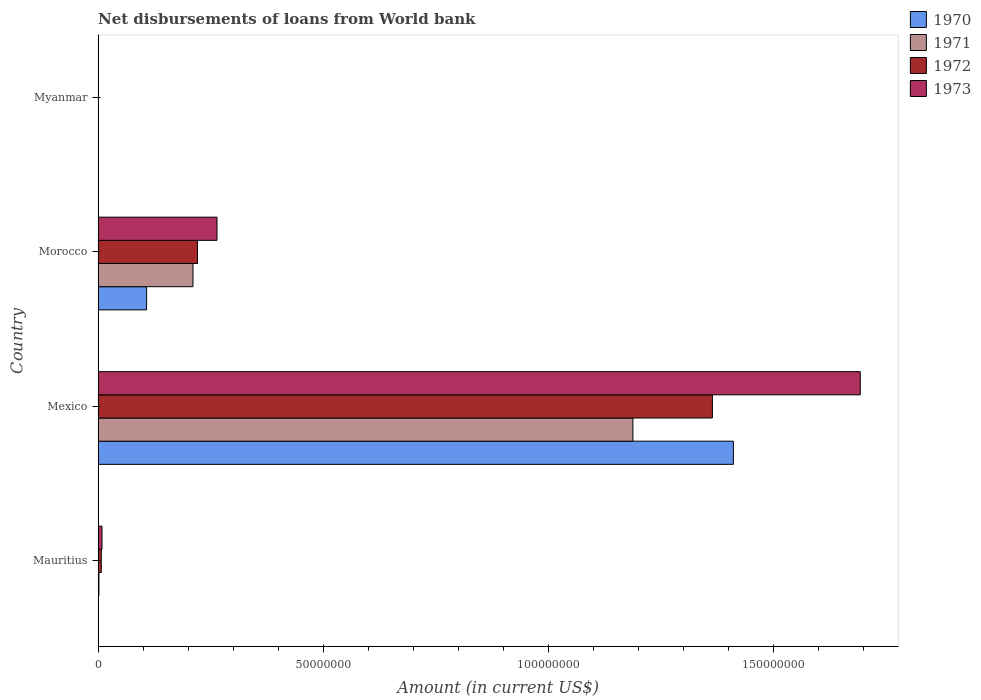Are the number of bars per tick equal to the number of legend labels?
Provide a short and direct response. No. How many bars are there on the 1st tick from the top?
Your answer should be very brief. 0. What is the label of the 2nd group of bars from the top?
Provide a short and direct response. Morocco. In how many cases, is the number of bars for a given country not equal to the number of legend labels?
Your answer should be very brief. 2. What is the amount of loan disbursed from World Bank in 1973 in Mexico?
Ensure brevity in your answer.  1.69e+08. Across all countries, what is the maximum amount of loan disbursed from World Bank in 1972?
Offer a very short reply. 1.36e+08. In which country was the amount of loan disbursed from World Bank in 1973 maximum?
Provide a succinct answer. Mexico. What is the total amount of loan disbursed from World Bank in 1970 in the graph?
Offer a terse response. 1.52e+08. What is the difference between the amount of loan disbursed from World Bank in 1972 in Mauritius and that in Morocco?
Keep it short and to the point. -2.14e+07. What is the difference between the amount of loan disbursed from World Bank in 1971 in Morocco and the amount of loan disbursed from World Bank in 1970 in Myanmar?
Offer a very short reply. 2.11e+07. What is the average amount of loan disbursed from World Bank in 1971 per country?
Offer a very short reply. 3.50e+07. What is the difference between the amount of loan disbursed from World Bank in 1972 and amount of loan disbursed from World Bank in 1973 in Mexico?
Offer a terse response. -3.28e+07. What is the ratio of the amount of loan disbursed from World Bank in 1973 in Mexico to that in Morocco?
Keep it short and to the point. 6.41. Is the amount of loan disbursed from World Bank in 1973 in Mexico less than that in Morocco?
Keep it short and to the point. No. What is the difference between the highest and the second highest amount of loan disbursed from World Bank in 1972?
Your response must be concise. 1.14e+08. What is the difference between the highest and the lowest amount of loan disbursed from World Bank in 1970?
Make the answer very short. 1.41e+08. In how many countries, is the amount of loan disbursed from World Bank in 1973 greater than the average amount of loan disbursed from World Bank in 1973 taken over all countries?
Provide a succinct answer. 1. Are the values on the major ticks of X-axis written in scientific E-notation?
Give a very brief answer. No. Does the graph contain any zero values?
Your response must be concise. Yes. Does the graph contain grids?
Keep it short and to the point. No. Where does the legend appear in the graph?
Your answer should be compact. Top right. How many legend labels are there?
Provide a succinct answer. 4. What is the title of the graph?
Give a very brief answer. Net disbursements of loans from World bank. What is the label or title of the Y-axis?
Keep it short and to the point. Country. What is the Amount (in current US$) in 1971 in Mauritius?
Provide a succinct answer. 1.99e+05. What is the Amount (in current US$) of 1972 in Mauritius?
Give a very brief answer. 7.17e+05. What is the Amount (in current US$) in 1973 in Mauritius?
Make the answer very short. 8.79e+05. What is the Amount (in current US$) in 1970 in Mexico?
Offer a very short reply. 1.41e+08. What is the Amount (in current US$) in 1971 in Mexico?
Your answer should be compact. 1.19e+08. What is the Amount (in current US$) of 1972 in Mexico?
Keep it short and to the point. 1.36e+08. What is the Amount (in current US$) in 1973 in Mexico?
Give a very brief answer. 1.69e+08. What is the Amount (in current US$) in 1970 in Morocco?
Offer a very short reply. 1.08e+07. What is the Amount (in current US$) in 1971 in Morocco?
Your answer should be compact. 2.11e+07. What is the Amount (in current US$) in 1972 in Morocco?
Provide a succinct answer. 2.21e+07. What is the Amount (in current US$) of 1973 in Morocco?
Your response must be concise. 2.64e+07. What is the Amount (in current US$) of 1973 in Myanmar?
Your answer should be compact. 0. Across all countries, what is the maximum Amount (in current US$) in 1970?
Your answer should be very brief. 1.41e+08. Across all countries, what is the maximum Amount (in current US$) of 1971?
Offer a terse response. 1.19e+08. Across all countries, what is the maximum Amount (in current US$) of 1972?
Your response must be concise. 1.36e+08. Across all countries, what is the maximum Amount (in current US$) of 1973?
Your answer should be compact. 1.69e+08. Across all countries, what is the minimum Amount (in current US$) of 1970?
Ensure brevity in your answer.  0. What is the total Amount (in current US$) of 1970 in the graph?
Keep it short and to the point. 1.52e+08. What is the total Amount (in current US$) of 1971 in the graph?
Your response must be concise. 1.40e+08. What is the total Amount (in current US$) of 1972 in the graph?
Make the answer very short. 1.59e+08. What is the total Amount (in current US$) of 1973 in the graph?
Your response must be concise. 1.97e+08. What is the difference between the Amount (in current US$) of 1971 in Mauritius and that in Mexico?
Your response must be concise. -1.19e+08. What is the difference between the Amount (in current US$) of 1972 in Mauritius and that in Mexico?
Give a very brief answer. -1.36e+08. What is the difference between the Amount (in current US$) of 1973 in Mauritius and that in Mexico?
Your answer should be very brief. -1.68e+08. What is the difference between the Amount (in current US$) of 1971 in Mauritius and that in Morocco?
Provide a short and direct response. -2.09e+07. What is the difference between the Amount (in current US$) of 1972 in Mauritius and that in Morocco?
Your response must be concise. -2.14e+07. What is the difference between the Amount (in current US$) in 1973 in Mauritius and that in Morocco?
Your answer should be compact. -2.55e+07. What is the difference between the Amount (in current US$) in 1970 in Mexico and that in Morocco?
Your answer should be compact. 1.30e+08. What is the difference between the Amount (in current US$) of 1971 in Mexico and that in Morocco?
Give a very brief answer. 9.77e+07. What is the difference between the Amount (in current US$) of 1972 in Mexico and that in Morocco?
Provide a short and direct response. 1.14e+08. What is the difference between the Amount (in current US$) in 1973 in Mexico and that in Morocco?
Your response must be concise. 1.43e+08. What is the difference between the Amount (in current US$) in 1971 in Mauritius and the Amount (in current US$) in 1972 in Mexico?
Your answer should be compact. -1.36e+08. What is the difference between the Amount (in current US$) in 1971 in Mauritius and the Amount (in current US$) in 1973 in Mexico?
Your answer should be compact. -1.69e+08. What is the difference between the Amount (in current US$) in 1972 in Mauritius and the Amount (in current US$) in 1973 in Mexico?
Your answer should be very brief. -1.69e+08. What is the difference between the Amount (in current US$) of 1971 in Mauritius and the Amount (in current US$) of 1972 in Morocco?
Your answer should be very brief. -2.19e+07. What is the difference between the Amount (in current US$) in 1971 in Mauritius and the Amount (in current US$) in 1973 in Morocco?
Provide a short and direct response. -2.62e+07. What is the difference between the Amount (in current US$) in 1972 in Mauritius and the Amount (in current US$) in 1973 in Morocco?
Provide a succinct answer. -2.57e+07. What is the difference between the Amount (in current US$) in 1970 in Mexico and the Amount (in current US$) in 1971 in Morocco?
Your answer should be very brief. 1.20e+08. What is the difference between the Amount (in current US$) in 1970 in Mexico and the Amount (in current US$) in 1972 in Morocco?
Keep it short and to the point. 1.19e+08. What is the difference between the Amount (in current US$) of 1970 in Mexico and the Amount (in current US$) of 1973 in Morocco?
Make the answer very short. 1.15e+08. What is the difference between the Amount (in current US$) of 1971 in Mexico and the Amount (in current US$) of 1972 in Morocco?
Provide a short and direct response. 9.67e+07. What is the difference between the Amount (in current US$) in 1971 in Mexico and the Amount (in current US$) in 1973 in Morocco?
Offer a terse response. 9.24e+07. What is the difference between the Amount (in current US$) in 1972 in Mexico and the Amount (in current US$) in 1973 in Morocco?
Ensure brevity in your answer.  1.10e+08. What is the average Amount (in current US$) of 1970 per country?
Provide a succinct answer. 3.80e+07. What is the average Amount (in current US$) of 1971 per country?
Your response must be concise. 3.50e+07. What is the average Amount (in current US$) in 1972 per country?
Your answer should be very brief. 3.98e+07. What is the average Amount (in current US$) in 1973 per country?
Make the answer very short. 4.91e+07. What is the difference between the Amount (in current US$) of 1971 and Amount (in current US$) of 1972 in Mauritius?
Your response must be concise. -5.18e+05. What is the difference between the Amount (in current US$) of 1971 and Amount (in current US$) of 1973 in Mauritius?
Make the answer very short. -6.80e+05. What is the difference between the Amount (in current US$) in 1972 and Amount (in current US$) in 1973 in Mauritius?
Offer a very short reply. -1.62e+05. What is the difference between the Amount (in current US$) of 1970 and Amount (in current US$) of 1971 in Mexico?
Your response must be concise. 2.23e+07. What is the difference between the Amount (in current US$) of 1970 and Amount (in current US$) of 1972 in Mexico?
Give a very brief answer. 4.66e+06. What is the difference between the Amount (in current US$) in 1970 and Amount (in current US$) in 1973 in Mexico?
Make the answer very short. -2.82e+07. What is the difference between the Amount (in current US$) of 1971 and Amount (in current US$) of 1972 in Mexico?
Your answer should be very brief. -1.77e+07. What is the difference between the Amount (in current US$) of 1971 and Amount (in current US$) of 1973 in Mexico?
Your answer should be very brief. -5.05e+07. What is the difference between the Amount (in current US$) in 1972 and Amount (in current US$) in 1973 in Mexico?
Keep it short and to the point. -3.28e+07. What is the difference between the Amount (in current US$) of 1970 and Amount (in current US$) of 1971 in Morocco?
Ensure brevity in your answer.  -1.03e+07. What is the difference between the Amount (in current US$) in 1970 and Amount (in current US$) in 1972 in Morocco?
Give a very brief answer. -1.13e+07. What is the difference between the Amount (in current US$) of 1970 and Amount (in current US$) of 1973 in Morocco?
Your response must be concise. -1.56e+07. What is the difference between the Amount (in current US$) of 1971 and Amount (in current US$) of 1972 in Morocco?
Provide a short and direct response. -1.01e+06. What is the difference between the Amount (in current US$) of 1971 and Amount (in current US$) of 1973 in Morocco?
Provide a succinct answer. -5.34e+06. What is the difference between the Amount (in current US$) of 1972 and Amount (in current US$) of 1973 in Morocco?
Your response must be concise. -4.33e+06. What is the ratio of the Amount (in current US$) of 1971 in Mauritius to that in Mexico?
Your answer should be very brief. 0. What is the ratio of the Amount (in current US$) in 1972 in Mauritius to that in Mexico?
Your response must be concise. 0.01. What is the ratio of the Amount (in current US$) of 1973 in Mauritius to that in Mexico?
Offer a terse response. 0.01. What is the ratio of the Amount (in current US$) of 1971 in Mauritius to that in Morocco?
Your answer should be very brief. 0.01. What is the ratio of the Amount (in current US$) in 1972 in Mauritius to that in Morocco?
Offer a terse response. 0.03. What is the ratio of the Amount (in current US$) in 1970 in Mexico to that in Morocco?
Your response must be concise. 13.09. What is the ratio of the Amount (in current US$) of 1971 in Mexico to that in Morocco?
Offer a very short reply. 5.63. What is the ratio of the Amount (in current US$) in 1972 in Mexico to that in Morocco?
Make the answer very short. 6.18. What is the ratio of the Amount (in current US$) of 1973 in Mexico to that in Morocco?
Make the answer very short. 6.41. What is the difference between the highest and the second highest Amount (in current US$) in 1971?
Ensure brevity in your answer.  9.77e+07. What is the difference between the highest and the second highest Amount (in current US$) in 1972?
Provide a succinct answer. 1.14e+08. What is the difference between the highest and the second highest Amount (in current US$) of 1973?
Offer a very short reply. 1.43e+08. What is the difference between the highest and the lowest Amount (in current US$) in 1970?
Make the answer very short. 1.41e+08. What is the difference between the highest and the lowest Amount (in current US$) in 1971?
Offer a very short reply. 1.19e+08. What is the difference between the highest and the lowest Amount (in current US$) of 1972?
Your answer should be compact. 1.36e+08. What is the difference between the highest and the lowest Amount (in current US$) of 1973?
Provide a succinct answer. 1.69e+08. 